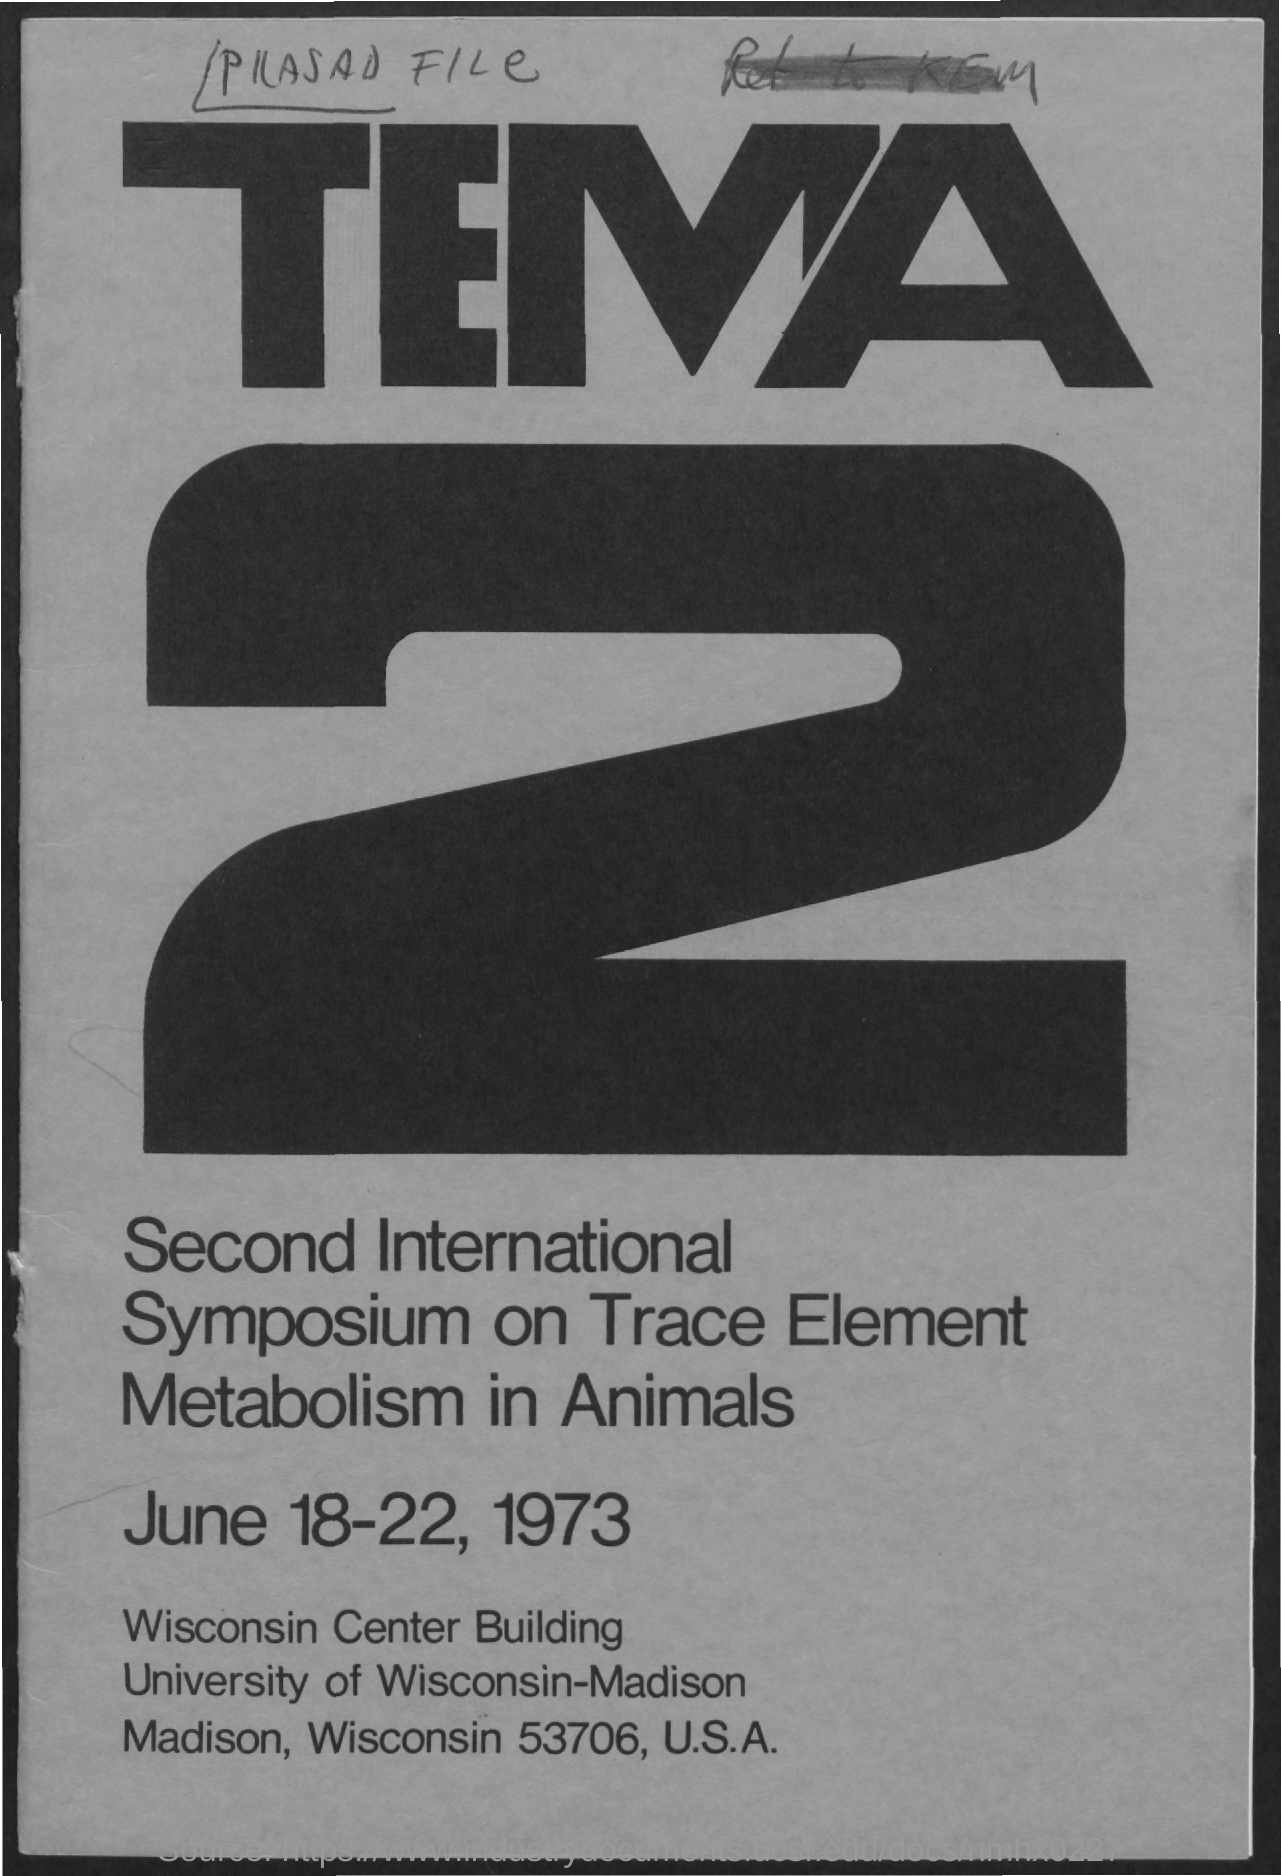When was the Second International Symposium on Trace Element Metabolism in Animals held?
Offer a very short reply. June 18-22, 1973. 